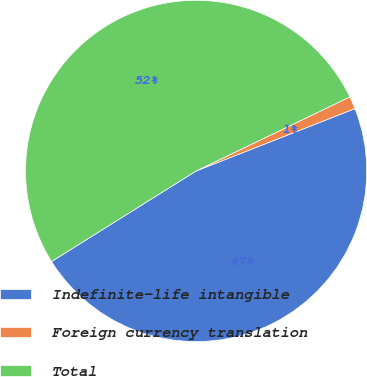Convert chart to OTSL. <chart><loc_0><loc_0><loc_500><loc_500><pie_chart><fcel>Indefinite-life intangible<fcel>Foreign currency translation<fcel>Total<nl><fcel>47.05%<fcel>1.19%<fcel>51.76%<nl></chart> 